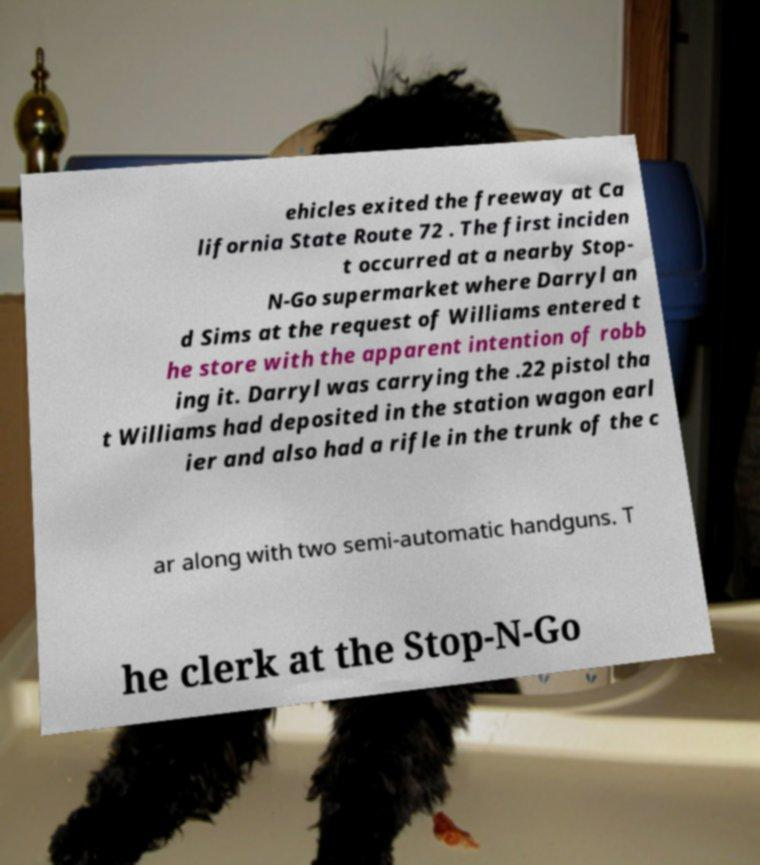Please identify and transcribe the text found in this image. ehicles exited the freeway at Ca lifornia State Route 72 . The first inciden t occurred at a nearby Stop- N-Go supermarket where Darryl an d Sims at the request of Williams entered t he store with the apparent intention of robb ing it. Darryl was carrying the .22 pistol tha t Williams had deposited in the station wagon earl ier and also had a rifle in the trunk of the c ar along with two semi-automatic handguns. T he clerk at the Stop-N-Go 